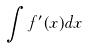<formula> <loc_0><loc_0><loc_500><loc_500>\int f ^ { \prime } ( x ) d x</formula> 